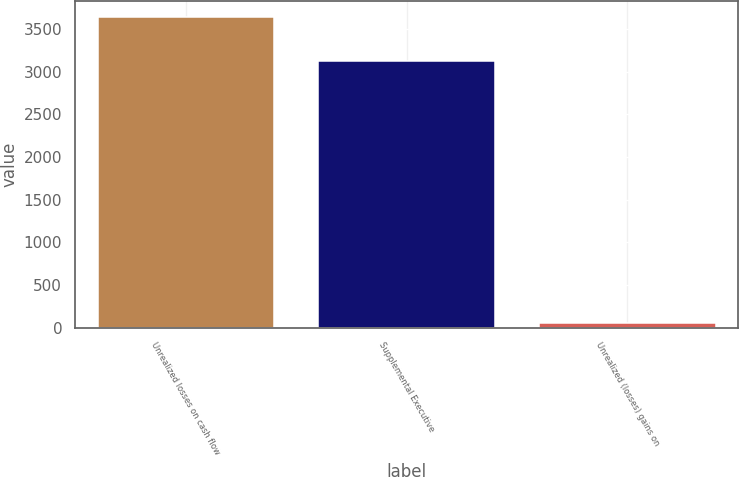Convert chart. <chart><loc_0><loc_0><loc_500><loc_500><bar_chart><fcel>Unrealized losses on cash flow<fcel>Supplemental Executive<fcel>Unrealized (losses) gains on<nl><fcel>3642<fcel>3129<fcel>54<nl></chart> 